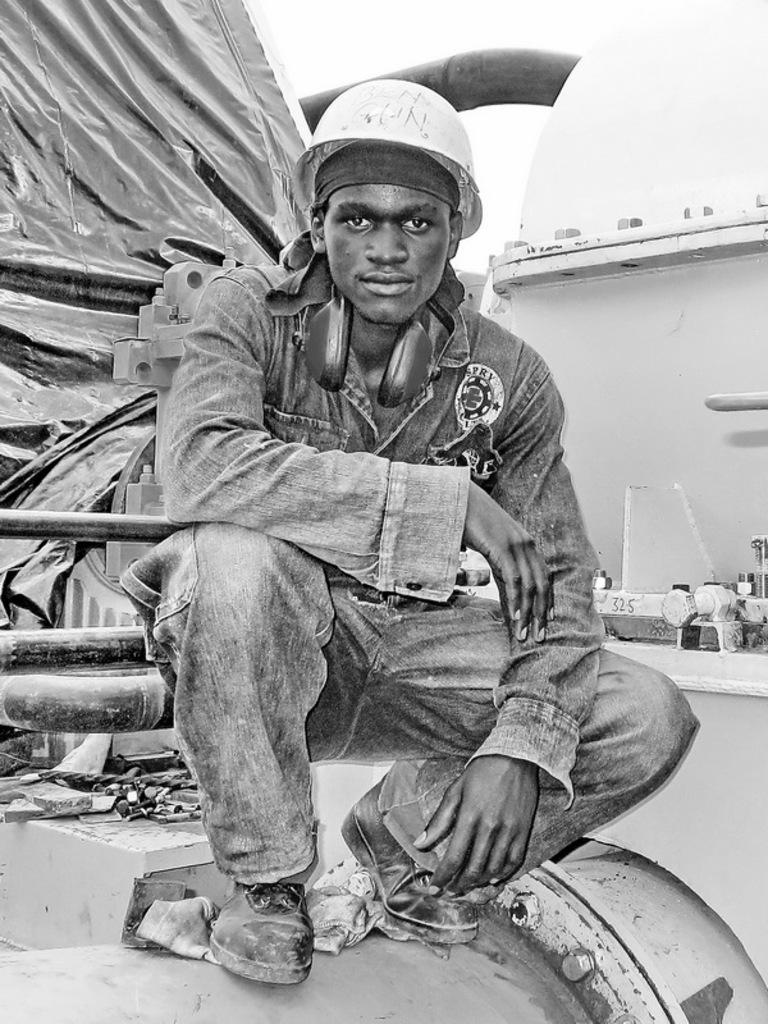What type of structure is present in the image? There is a house in the image. What is covering something in the image? There is a cover in the image. What can be seen in the background of the image? The sky is visible in the image. Who is present in the image and what is he wearing? There is a man wearing a helmet in the image. Where is the man sitting in the image? The man is sitting in the front of the image. What type of mint is growing in the image? There is no mint present in the image. What order is the man following in the image? There is no order or sequence of actions being followed in the image. 